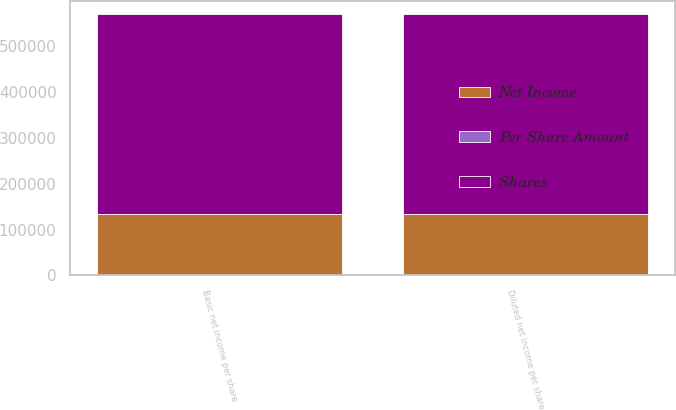Convert chart to OTSL. <chart><loc_0><loc_0><loc_500><loc_500><stacked_bar_chart><ecel><fcel>Basic net income per share<fcel>Diluted net income per share<nl><fcel>Shares<fcel>437120<fcel>437120<nl><fcel>Net Income<fcel>132905<fcel>133813<nl><fcel>Per Share Amount<fcel>3.29<fcel>3.27<nl></chart> 